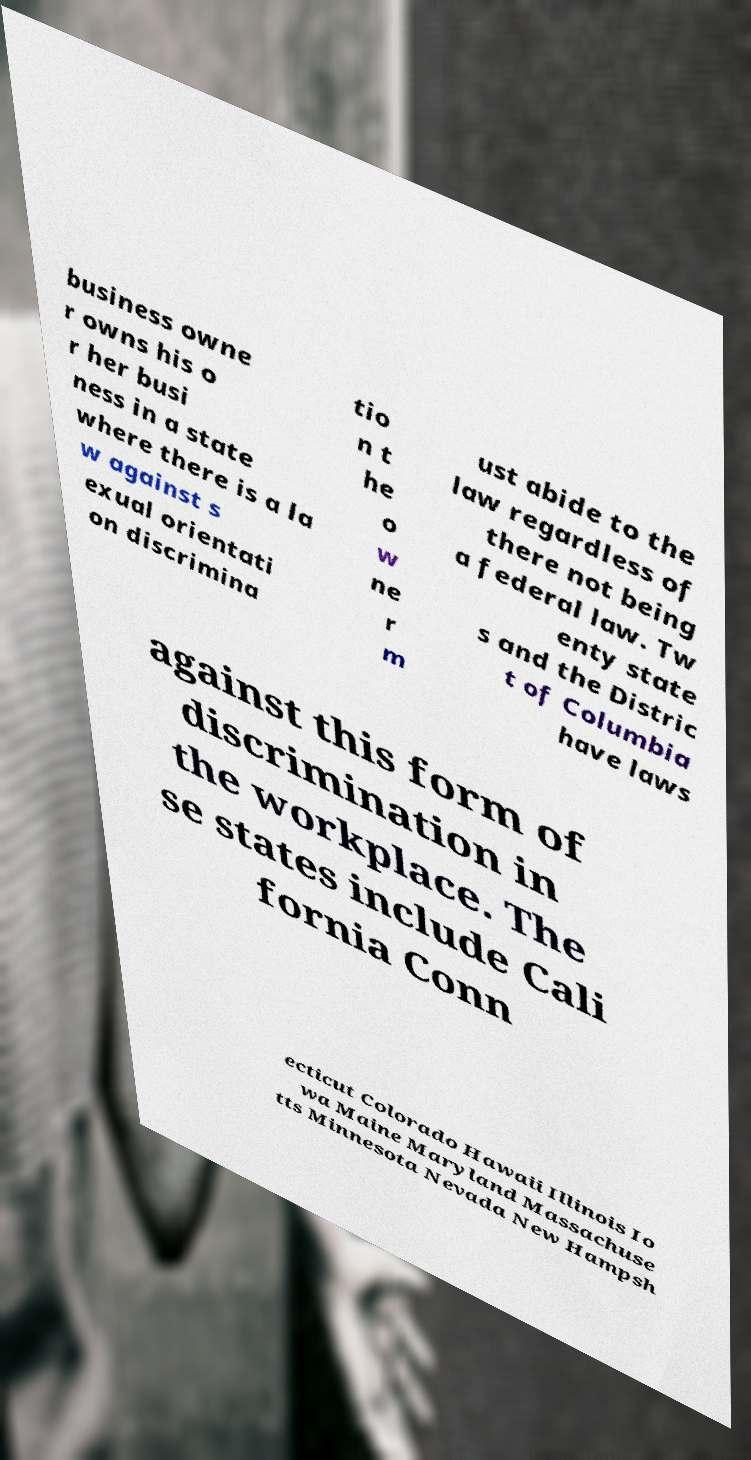What messages or text are displayed in this image? I need them in a readable, typed format. business owne r owns his o r her busi ness in a state where there is a la w against s exual orientati on discrimina tio n t he o w ne r m ust abide to the law regardless of there not being a federal law. Tw enty state s and the Distric t of Columbia have laws against this form of discrimination in the workplace. The se states include Cali fornia Conn ecticut Colorado Hawaii Illinois Io wa Maine Maryland Massachuse tts Minnesota Nevada New Hampsh 